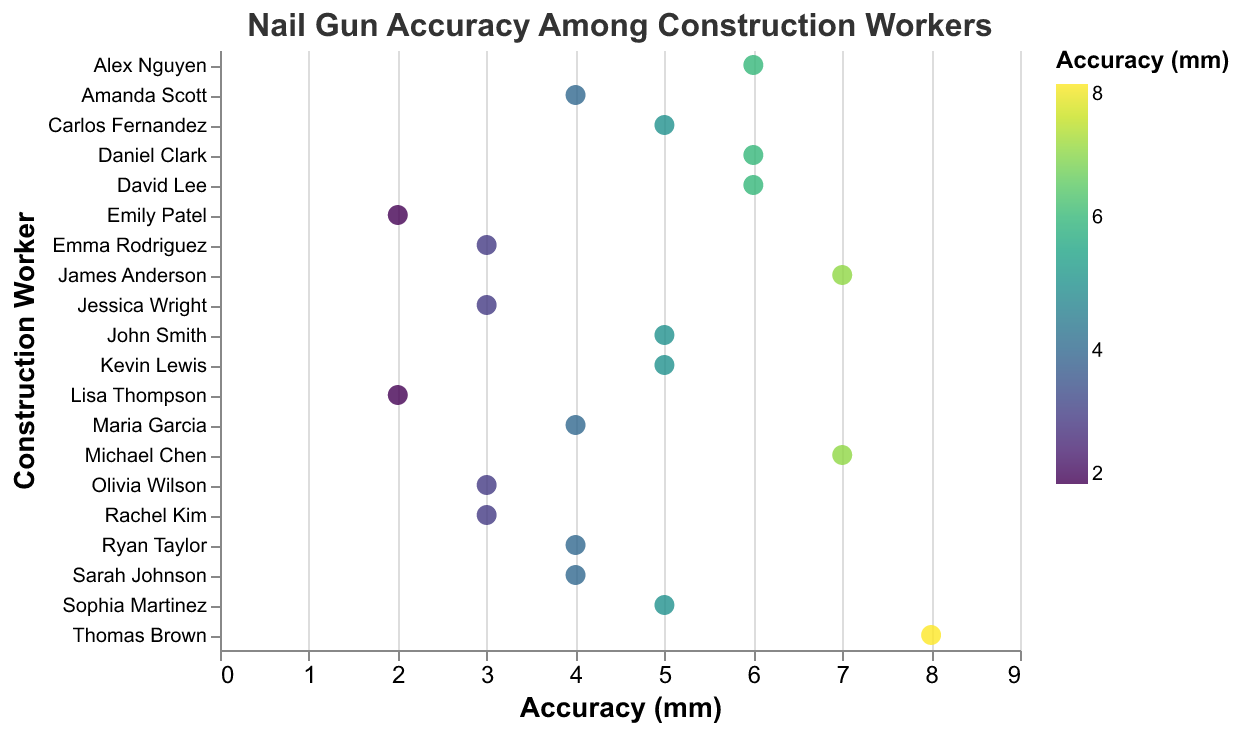What is the title of the plot? The title of the plot can be observed at the top of the figure and it states what the plot is about.
Answer: Nail Gun Accuracy Among Construction Workers What is the range of accuracy measurements in the plot? The x-axis shows the accuracy in millimeters, with a range starting from 0 mm to 9 mm.
Answer: 0 to 9 mm How many workers have an accuracy measurement of 4 mm? From the figure, we can count the number of circles on the 4 mm tick mark.
Answer: 5 Which worker has the highest accuracy measurement? By looking at the farthest right circle on the x-axis, we can identify the worker with the highest value.
Answer: Thomas Brown What is the average accuracy measurement among all workers? Sum up all the accuracy measurements and divide by the number of workers. (5+3+7+4+6+2+5+3+8+4+6+3+7+5+4+2+6+3+5+4)/20 = 98/20 = 4.9
Answer: 4.9 mm How many workers have an accuracy measurement of 3 mm or below? Count the number of circles at 3 mm, 2 mm, and below on the x-axis.
Answer: 6 Which two workers have an accuracy measurement of 7 mm? Identify the two circles at the 7 mm mark and check their corresponding worker names using the tooltip or the plot.
Answer: Michael Chen and James Anderson What is the difference in accuracy measurements between the most and least accurate workers? Subtract the smallest accuracy measurement from the largest (8 mm - 2 mm).
Answer: 6 mm Compare the accuracy measurements of Michael Chen and David Lee. Who is more accurate? Check the accuracy measurements of both workers on the x-axis. Michael Chen has 7 mm, and David Lee has 6 mm. David Lee is more accurate because a lower mm value indicates higher accuracy.
Answer: David Lee How does the accuracy measurement of Sarah Johnson compare to that of Amanda Scott? Both Sarah Johnson and Amanda Scott have an accuracy measurement of 4 mm, which can be seen by locating their points on the plot.
Answer: They are equal 